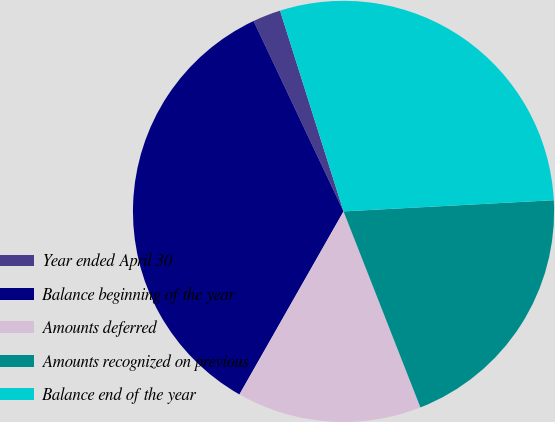Convert chart to OTSL. <chart><loc_0><loc_0><loc_500><loc_500><pie_chart><fcel>Year ended April 30<fcel>Balance beginning of the year<fcel>Amounts deferred<fcel>Amounts recognized on previous<fcel>Balance end of the year<nl><fcel>2.15%<fcel>34.75%<fcel>14.18%<fcel>19.9%<fcel>29.03%<nl></chart> 